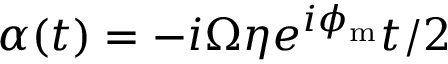<formula> <loc_0><loc_0><loc_500><loc_500>\alpha ( t ) = - i \Omega \eta e ^ { i \phi _ { m } } t / 2</formula> 